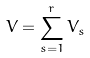Convert formula to latex. <formula><loc_0><loc_0><loc_500><loc_500>V = \sum _ { s = 1 } ^ { r } V _ { s }</formula> 